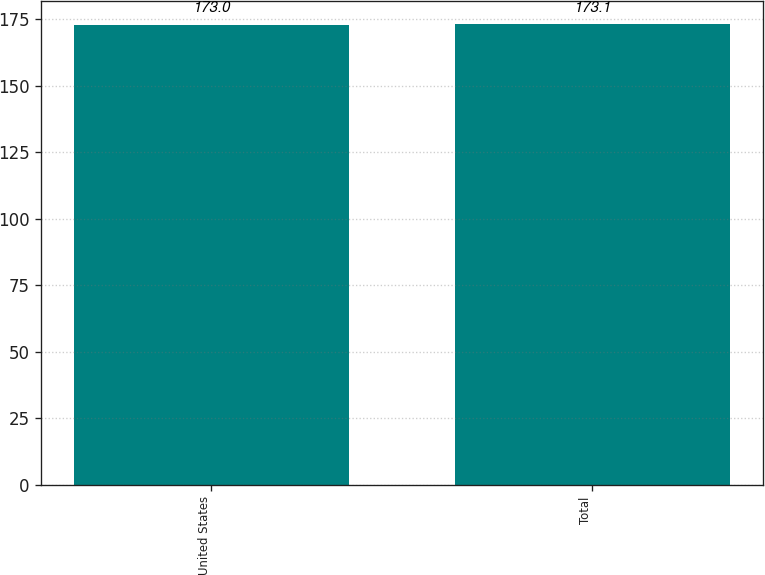<chart> <loc_0><loc_0><loc_500><loc_500><bar_chart><fcel>United States<fcel>Total<nl><fcel>173<fcel>173.1<nl></chart> 